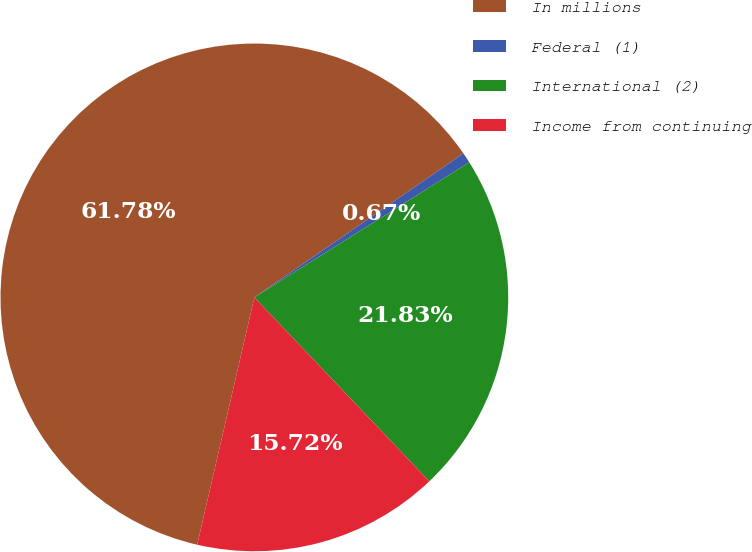Convert chart to OTSL. <chart><loc_0><loc_0><loc_500><loc_500><pie_chart><fcel>In millions<fcel>Federal (1)<fcel>International (2)<fcel>Income from continuing<nl><fcel>61.79%<fcel>0.67%<fcel>21.83%<fcel>15.72%<nl></chart> 